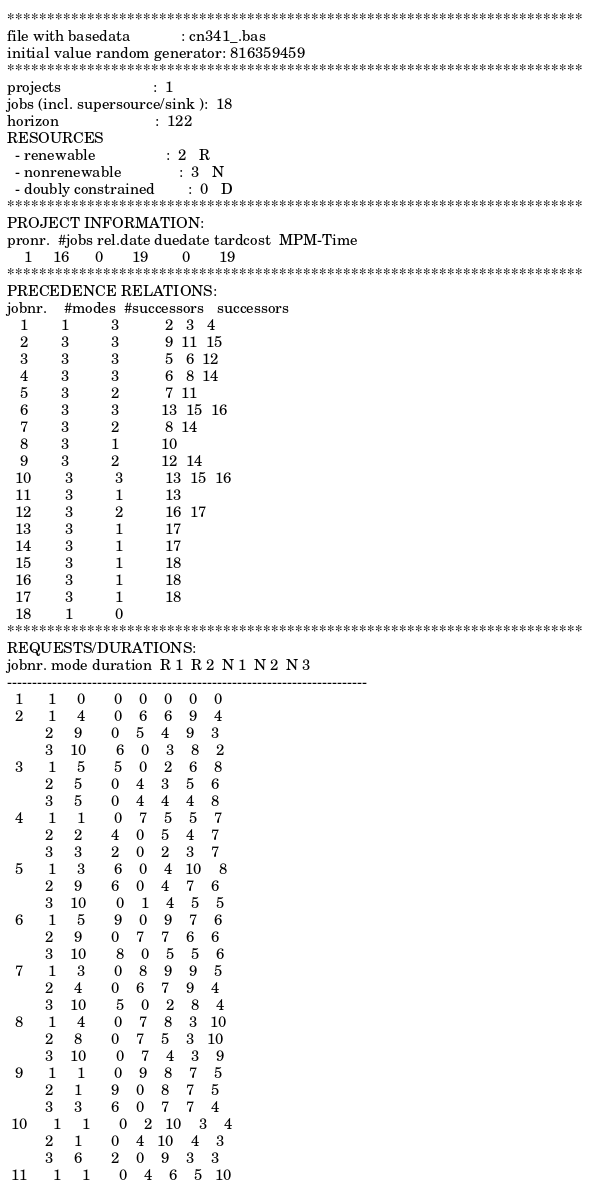<code> <loc_0><loc_0><loc_500><loc_500><_ObjectiveC_>************************************************************************
file with basedata            : cn341_.bas
initial value random generator: 816359459
************************************************************************
projects                      :  1
jobs (incl. supersource/sink ):  18
horizon                       :  122
RESOURCES
  - renewable                 :  2   R
  - nonrenewable              :  3   N
  - doubly constrained        :  0   D
************************************************************************
PROJECT INFORMATION:
pronr.  #jobs rel.date duedate tardcost  MPM-Time
    1     16      0       19        0       19
************************************************************************
PRECEDENCE RELATIONS:
jobnr.    #modes  #successors   successors
   1        1          3           2   3   4
   2        3          3           9  11  15
   3        3          3           5   6  12
   4        3          3           6   8  14
   5        3          2           7  11
   6        3          3          13  15  16
   7        3          2           8  14
   8        3          1          10
   9        3          2          12  14
  10        3          3          13  15  16
  11        3          1          13
  12        3          2          16  17
  13        3          1          17
  14        3          1          17
  15        3          1          18
  16        3          1          18
  17        3          1          18
  18        1          0        
************************************************************************
REQUESTS/DURATIONS:
jobnr. mode duration  R 1  R 2  N 1  N 2  N 3
------------------------------------------------------------------------
  1      1     0       0    0    0    0    0
  2      1     4       0    6    6    9    4
         2     9       0    5    4    9    3
         3    10       6    0    3    8    2
  3      1     5       5    0    2    6    8
         2     5       0    4    3    5    6
         3     5       0    4    4    4    8
  4      1     1       0    7    5    5    7
         2     2       4    0    5    4    7
         3     3       2    0    2    3    7
  5      1     3       6    0    4   10    8
         2     9       6    0    4    7    6
         3    10       0    1    4    5    5
  6      1     5       9    0    9    7    6
         2     9       0    7    7    6    6
         3    10       8    0    5    5    6
  7      1     3       0    8    9    9    5
         2     4       0    6    7    9    4
         3    10       5    0    2    8    4
  8      1     4       0    7    8    3   10
         2     8       0    7    5    3   10
         3    10       0    7    4    3    9
  9      1     1       0    9    8    7    5
         2     1       9    0    8    7    5
         3     3       6    0    7    7    4
 10      1     1       0    2   10    3    4
         2     1       0    4   10    4    3
         3     6       2    0    9    3    3
 11      1     1       0    4    6    5   10</code> 